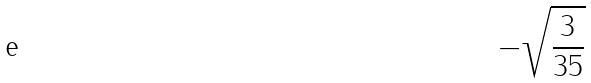Convert formula to latex. <formula><loc_0><loc_0><loc_500><loc_500>- \sqrt { \frac { 3 } { 3 5 } }</formula> 